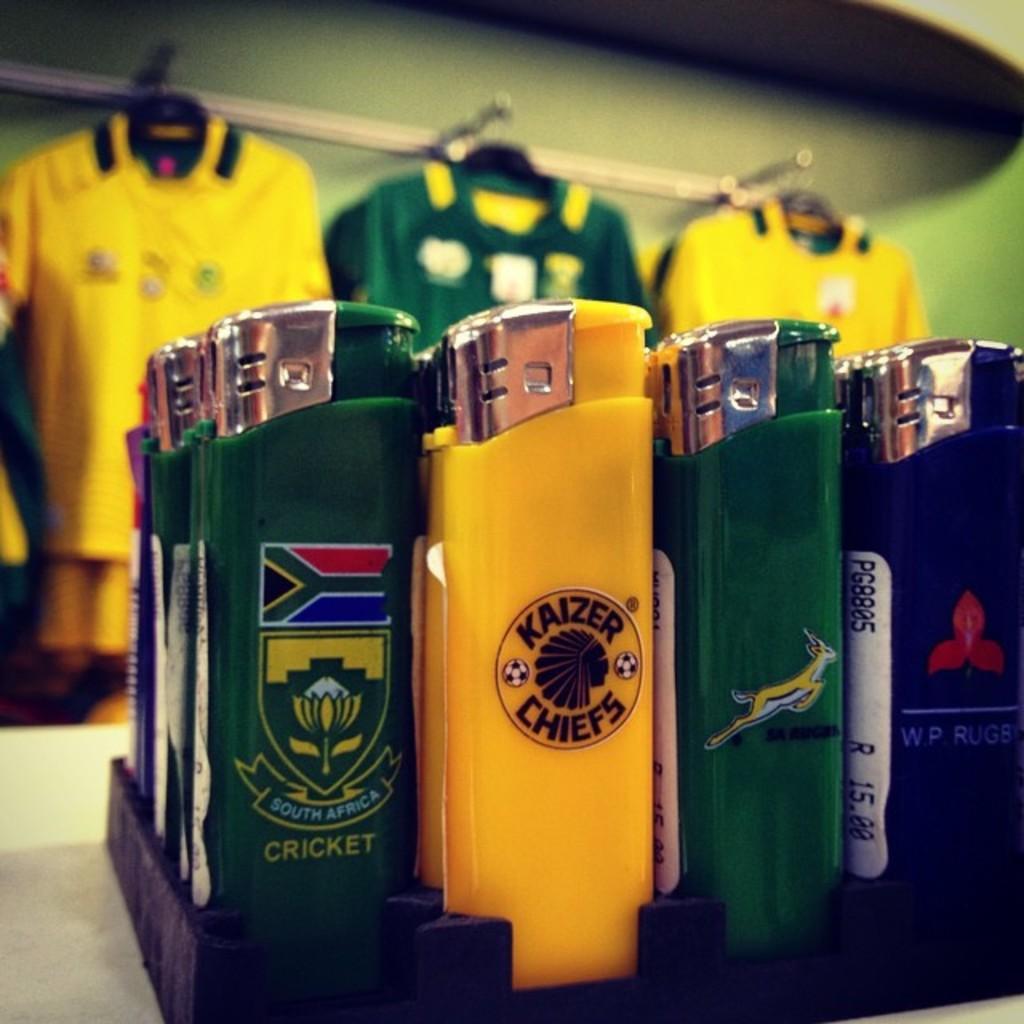Please provide a concise description of this image. In the image we can see liters of different colors. Here we can see the T-shirts hang to the hangers and the background is slightly blurred. 